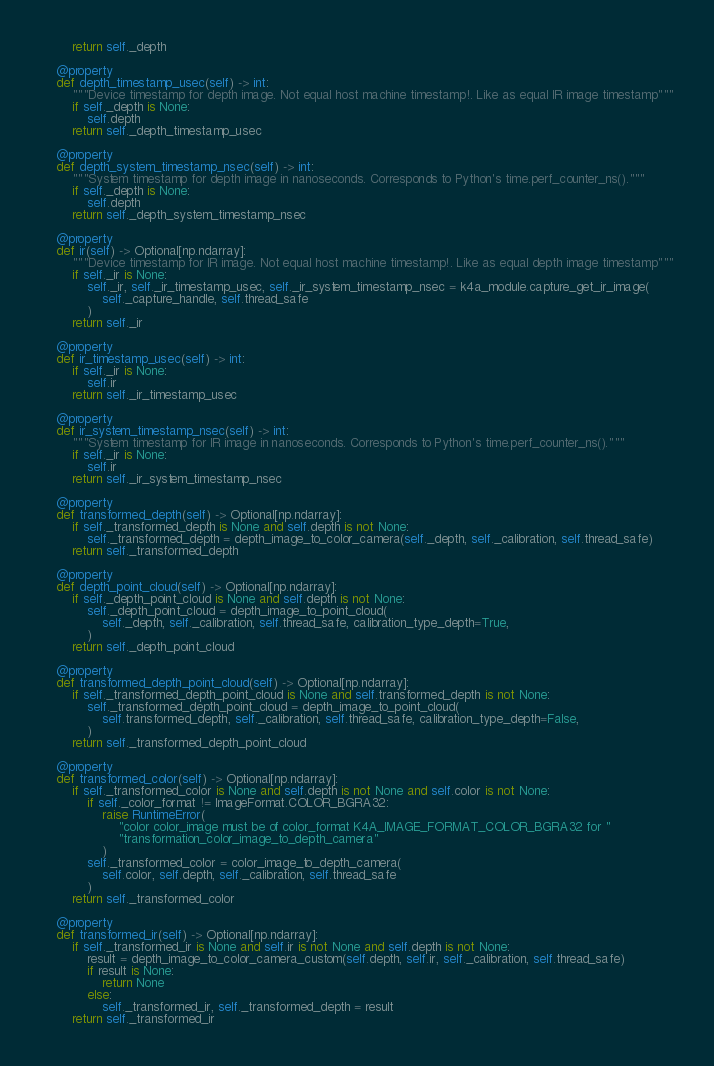<code> <loc_0><loc_0><loc_500><loc_500><_Python_>        return self._depth

    @property
    def depth_timestamp_usec(self) -> int:
        """Device timestamp for depth image. Not equal host machine timestamp!. Like as equal IR image timestamp"""
        if self._depth is None:
            self.depth
        return self._depth_timestamp_usec

    @property
    def depth_system_timestamp_nsec(self) -> int:
        """System timestamp for depth image in nanoseconds. Corresponds to Python's time.perf_counter_ns()."""
        if self._depth is None:
            self.depth
        return self._depth_system_timestamp_nsec

    @property
    def ir(self) -> Optional[np.ndarray]:
        """Device timestamp for IR image. Not equal host machine timestamp!. Like as equal depth image timestamp"""
        if self._ir is None:
            self._ir, self._ir_timestamp_usec, self._ir_system_timestamp_nsec = k4a_module.capture_get_ir_image(
                self._capture_handle, self.thread_safe
            )
        return self._ir

    @property
    def ir_timestamp_usec(self) -> int:
        if self._ir is None:
            self.ir
        return self._ir_timestamp_usec

    @property
    def ir_system_timestamp_nsec(self) -> int:
        """System timestamp for IR image in nanoseconds. Corresponds to Python's time.perf_counter_ns()."""
        if self._ir is None:
            self.ir
        return self._ir_system_timestamp_nsec

    @property
    def transformed_depth(self) -> Optional[np.ndarray]:
        if self._transformed_depth is None and self.depth is not None:
            self._transformed_depth = depth_image_to_color_camera(self._depth, self._calibration, self.thread_safe)
        return self._transformed_depth

    @property
    def depth_point_cloud(self) -> Optional[np.ndarray]:
        if self._depth_point_cloud is None and self.depth is not None:
            self._depth_point_cloud = depth_image_to_point_cloud(
                self._depth, self._calibration, self.thread_safe, calibration_type_depth=True,
            )
        return self._depth_point_cloud

    @property
    def transformed_depth_point_cloud(self) -> Optional[np.ndarray]:
        if self._transformed_depth_point_cloud is None and self.transformed_depth is not None:
            self._transformed_depth_point_cloud = depth_image_to_point_cloud(
                self.transformed_depth, self._calibration, self.thread_safe, calibration_type_depth=False,
            )
        return self._transformed_depth_point_cloud

    @property
    def transformed_color(self) -> Optional[np.ndarray]:
        if self._transformed_color is None and self.depth is not None and self.color is not None:
            if self._color_format != ImageFormat.COLOR_BGRA32:
                raise RuntimeError(
                    "color color_image must be of color_format K4A_IMAGE_FORMAT_COLOR_BGRA32 for "
                    "transformation_color_image_to_depth_camera"
                )
            self._transformed_color = color_image_to_depth_camera(
                self.color, self.depth, self._calibration, self.thread_safe
            )
        return self._transformed_color

    @property
    def transformed_ir(self) -> Optional[np.ndarray]:
        if self._transformed_ir is None and self.ir is not None and self.depth is not None:
            result = depth_image_to_color_camera_custom(self.depth, self.ir, self._calibration, self.thread_safe)
            if result is None:
                return None
            else:
                self._transformed_ir, self._transformed_depth = result
        return self._transformed_ir
</code> 